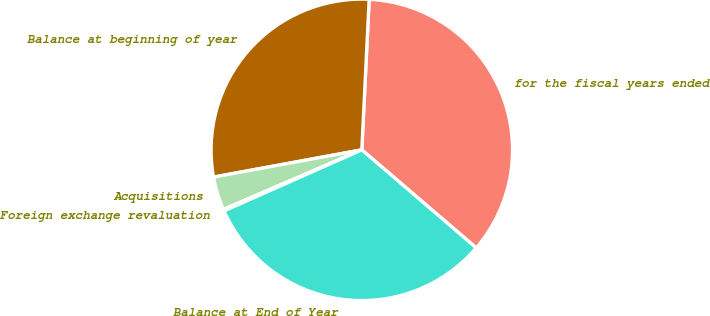<chart> <loc_0><loc_0><loc_500><loc_500><pie_chart><fcel>for the fiscal years ended<fcel>Balance at beginning of year<fcel>Acquisitions<fcel>Foreign exchange revaluation<fcel>Balance at End of Year<nl><fcel>35.5%<fcel>28.67%<fcel>3.58%<fcel>0.17%<fcel>32.08%<nl></chart> 